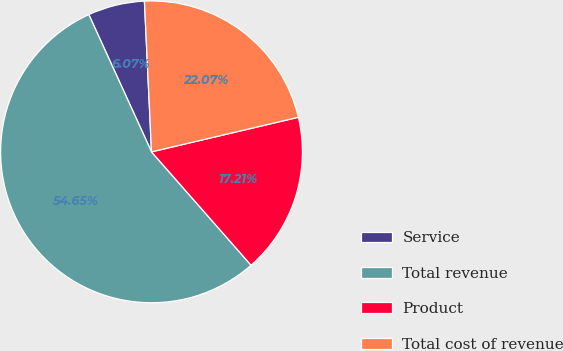Convert chart. <chart><loc_0><loc_0><loc_500><loc_500><pie_chart><fcel>Service<fcel>Total revenue<fcel>Product<fcel>Total cost of revenue<nl><fcel>6.07%<fcel>54.65%<fcel>17.21%<fcel>22.07%<nl></chart> 